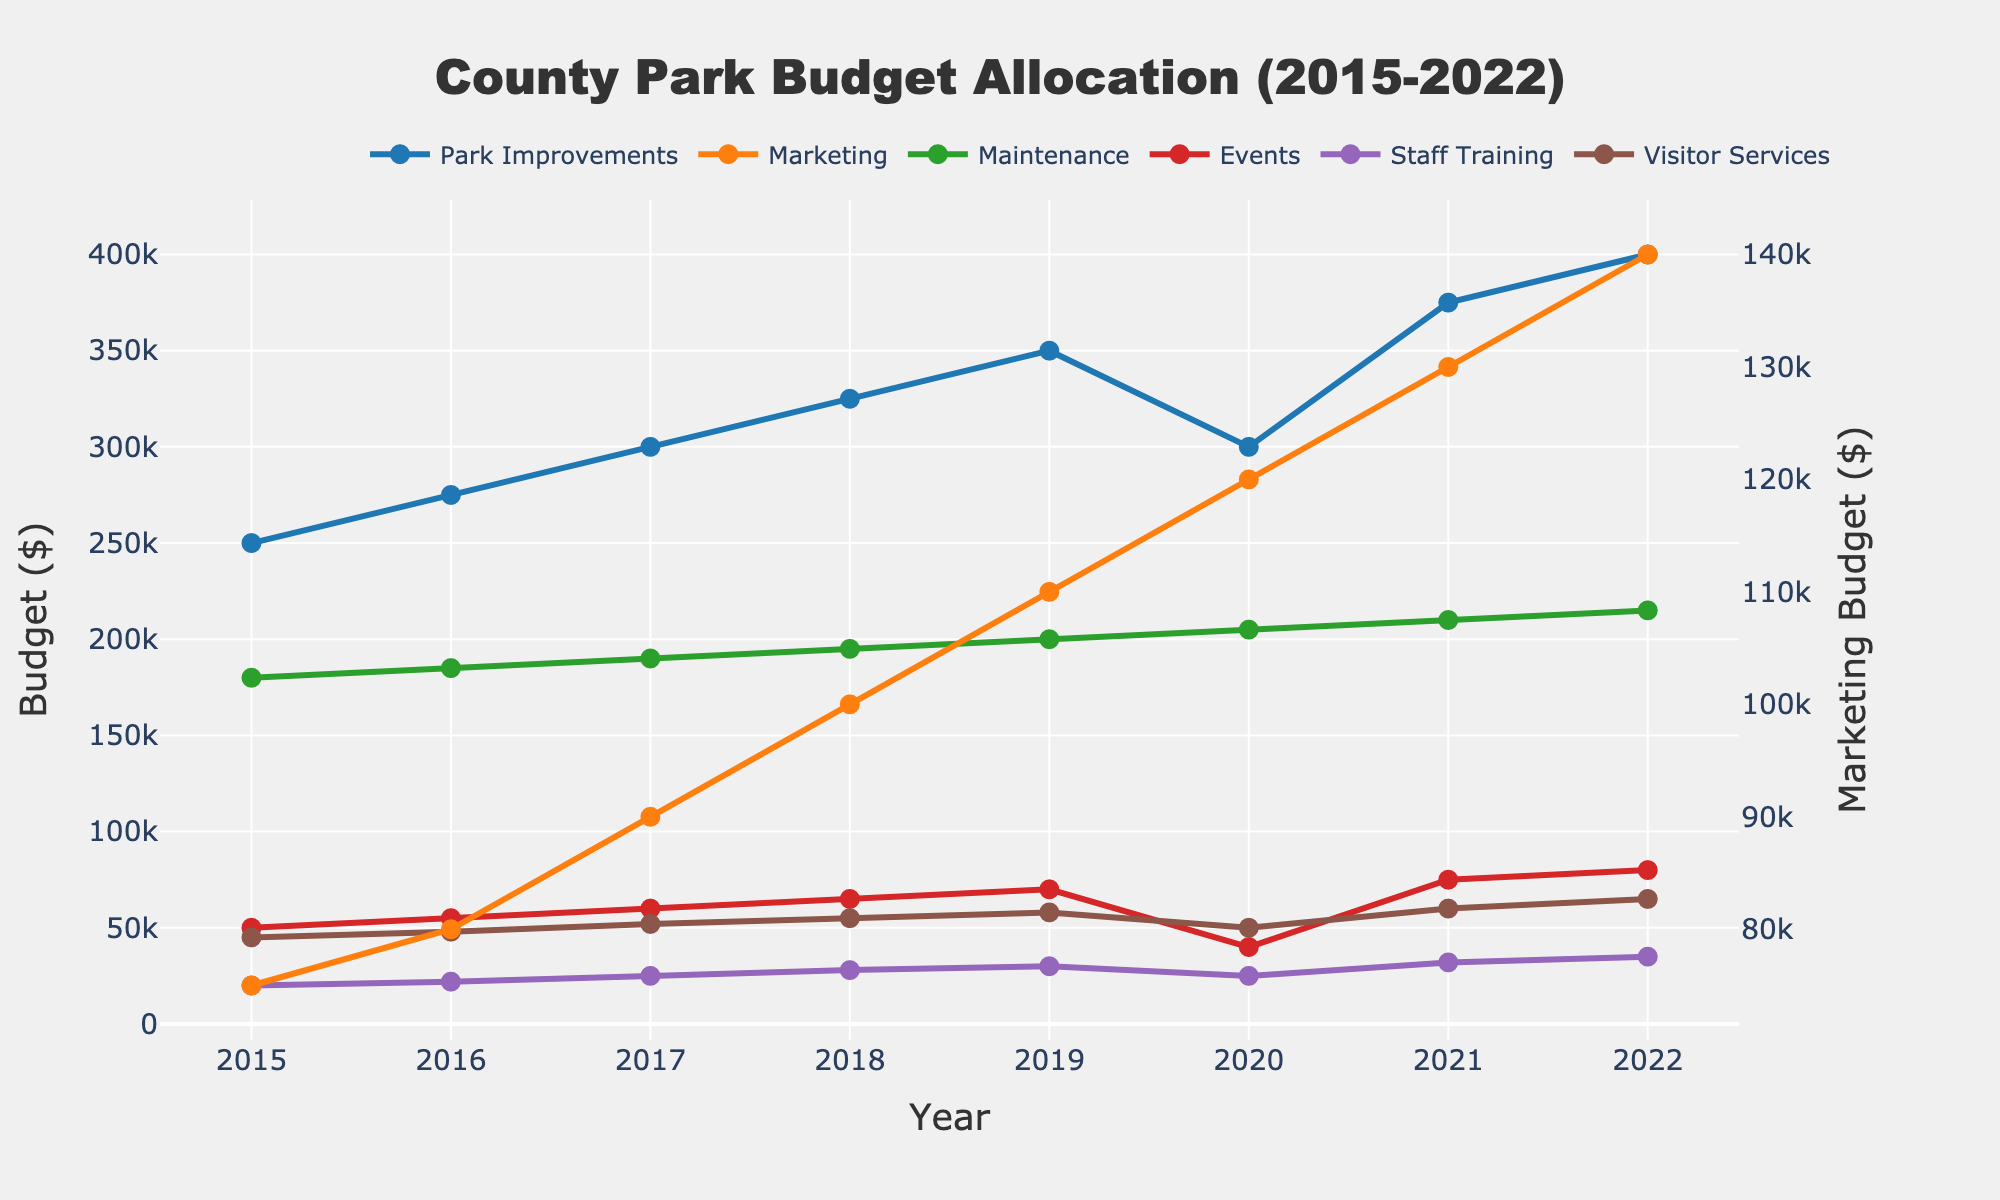What is the highest budget allocation for park improvements in a single year? To find the highest budget allocation for park improvements, look for the maximum value in the "Park Improvements" line on the graph. The line peaks at $400,000 in 2022.
Answer: $400,000 Which year saw the smallest budget for events, and how much was it? Identify the lowest point on the "Events" line. The lowest value is $40,000 in 2020.
Answer: 2020, $40,000 Compare the budgets for marketing in 2015 and 2022. By how much did it increase? Look at the "Marketing" line for the values in 2015 and 2022. In 2015, the budget was $75,000 and in 2022, it was $140,000. The increase is $140,000 - $75,000 = $65,000.
Answer: $65,000 What is the average budget for maintenance over the years? Add all the values for "Maintenance" from 2015 to 2022 and divide by the number of years. ($180,000 + $185,000 + $190,000 + $195,000 + $200,000 + $205,000 + $210,000 + $215,000) / 8.
Answer: $197,500 In which year did staff training receive the highest percentage increase from the previous year? Calculate the year-over-year percentage increase for each year, and identify the year with the largest increase. The largest increase occurred between 2020 and 2021: (($32,000 - $25,000) / $25,000) * 100 = 28%.
Answer: 2021 Which category had the most consistent budget allocation throughout the years? The most consistent budget will show the least fluctuation in its line on the chart. "Maintenance" has the least fluctuation.
Answer: Maintenance Which two spending categories have the least difference in their budget allocations in 2022? Compare the values for all spending categories in 2022 and find the smallest difference. "Events" ($80,000) and "Visitor Services" ($65,000) have a difference of $15,000.
Answer: Events and Visitor Services What is the total increase in the budget for visitor services from 2015 to 2022? Subtract the 2015 visitor services budget from the 2022 budget. $65,000 (2022) - $45,000 (2015) = $20,000.
Answer: $20,000 What is the combined budget for marketing and events in 2020? Add the budgets for "Marketing" and "Events" in 2020. $120,000 (Marketing) + $40,000 (Events) = $160,000.
Answer: $160,000 